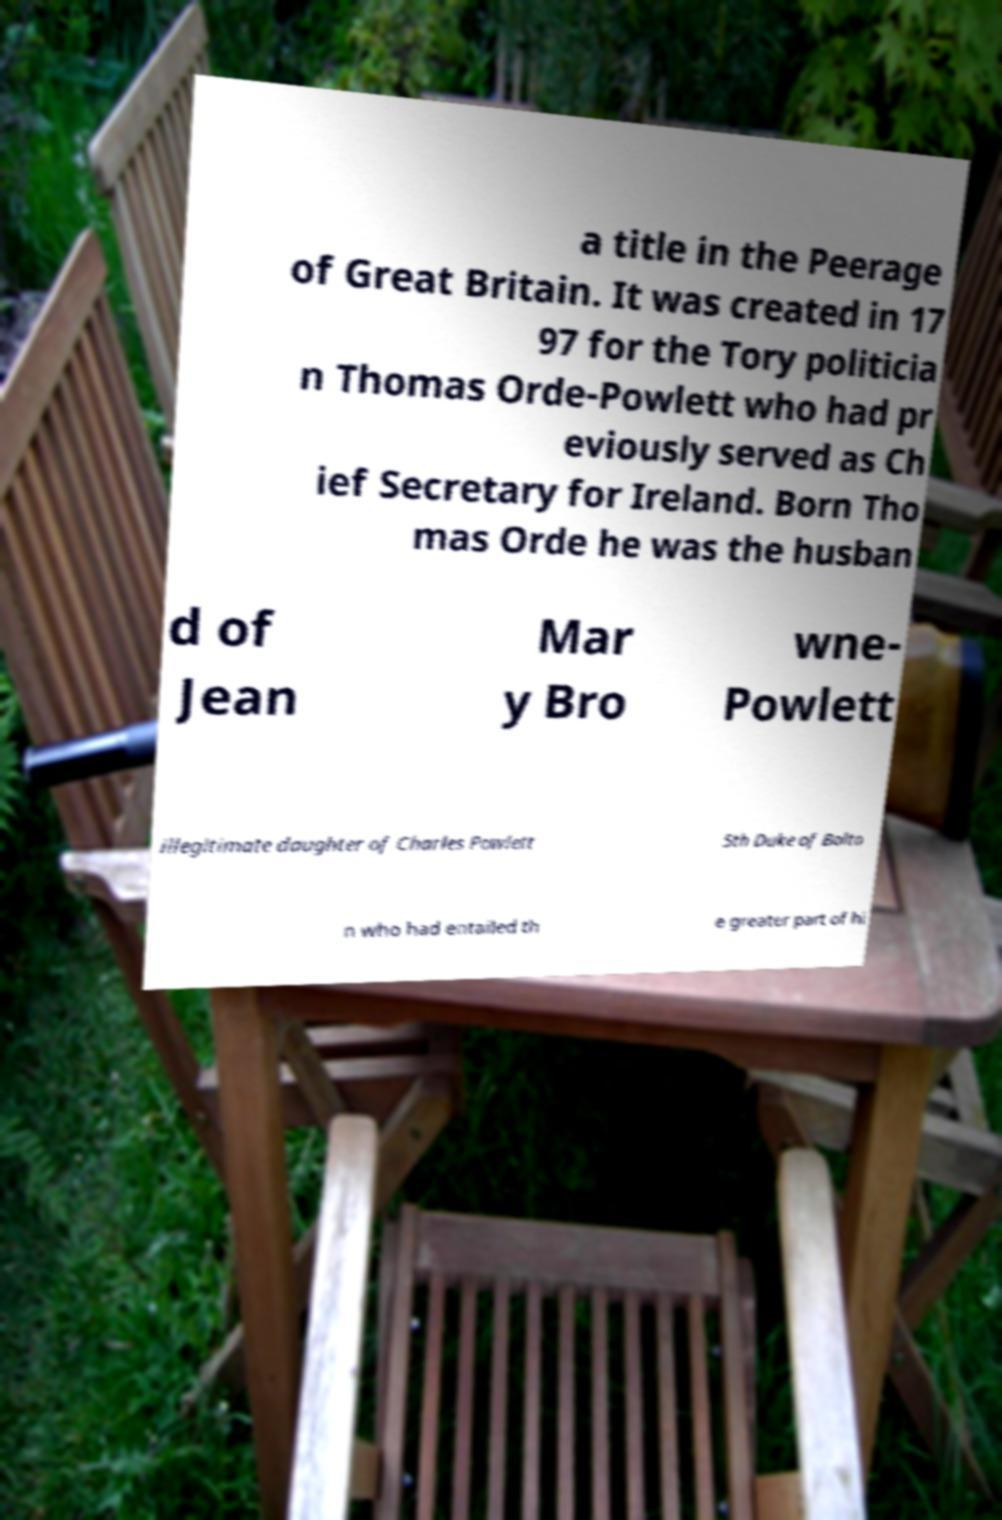There's text embedded in this image that I need extracted. Can you transcribe it verbatim? a title in the Peerage of Great Britain. It was created in 17 97 for the Tory politicia n Thomas Orde-Powlett who had pr eviously served as Ch ief Secretary for Ireland. Born Tho mas Orde he was the husban d of Jean Mar y Bro wne- Powlett illegitimate daughter of Charles Powlett 5th Duke of Bolto n who had entailed th e greater part of hi 